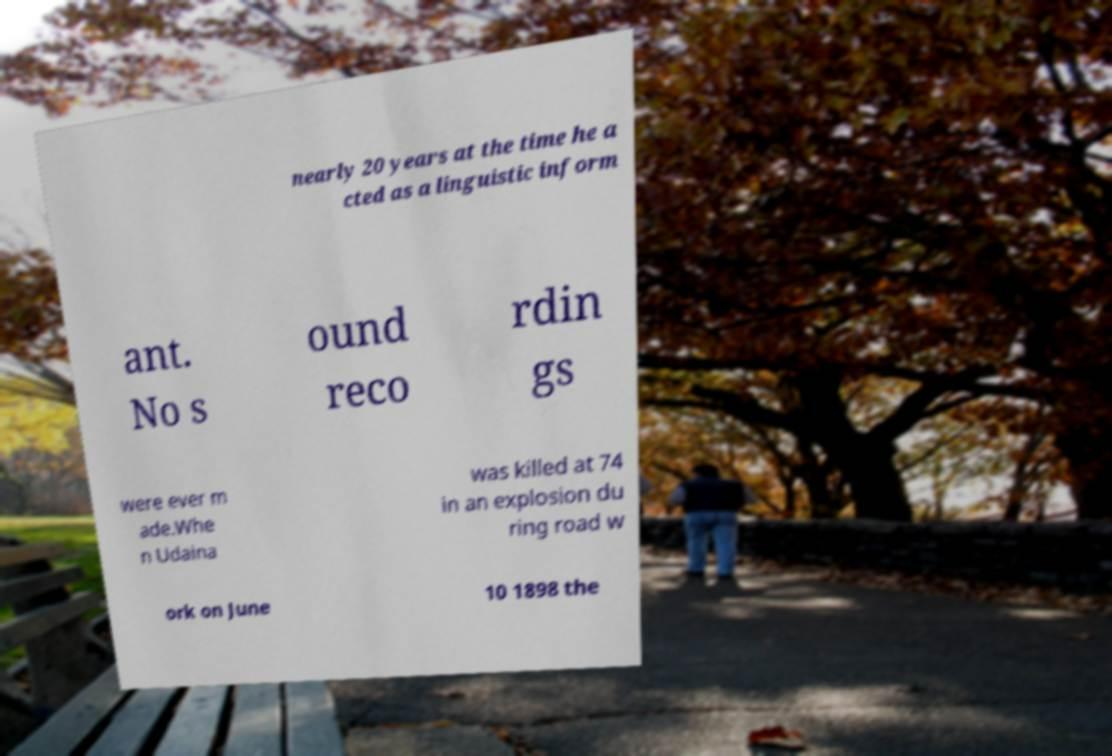There's text embedded in this image that I need extracted. Can you transcribe it verbatim? nearly 20 years at the time he a cted as a linguistic inform ant. No s ound reco rdin gs were ever m ade.Whe n Udaina was killed at 74 in an explosion du ring road w ork on June 10 1898 the 